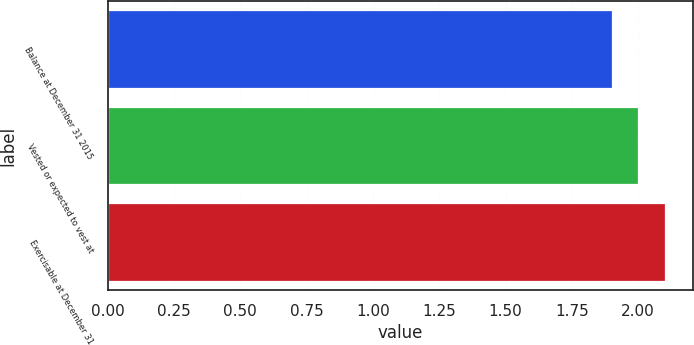<chart> <loc_0><loc_0><loc_500><loc_500><bar_chart><fcel>Balance at December 31 2015<fcel>Vested or expected to vest at<fcel>Exercisable at December 31<nl><fcel>1.9<fcel>2<fcel>2.1<nl></chart> 